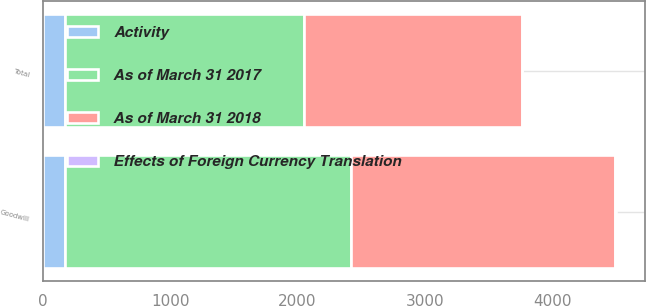Convert chart. <chart><loc_0><loc_0><loc_500><loc_500><stacked_bar_chart><ecel><fcel>Goodwill<fcel>Total<nl><fcel>As of March 31 2018<fcel>2075<fcel>1707<nl><fcel>Activity<fcel>171<fcel>171<nl><fcel>Effects of Foreign Currency Translation<fcel>5<fcel>5<nl><fcel>As of March 31 2017<fcel>2251<fcel>1883<nl></chart> 